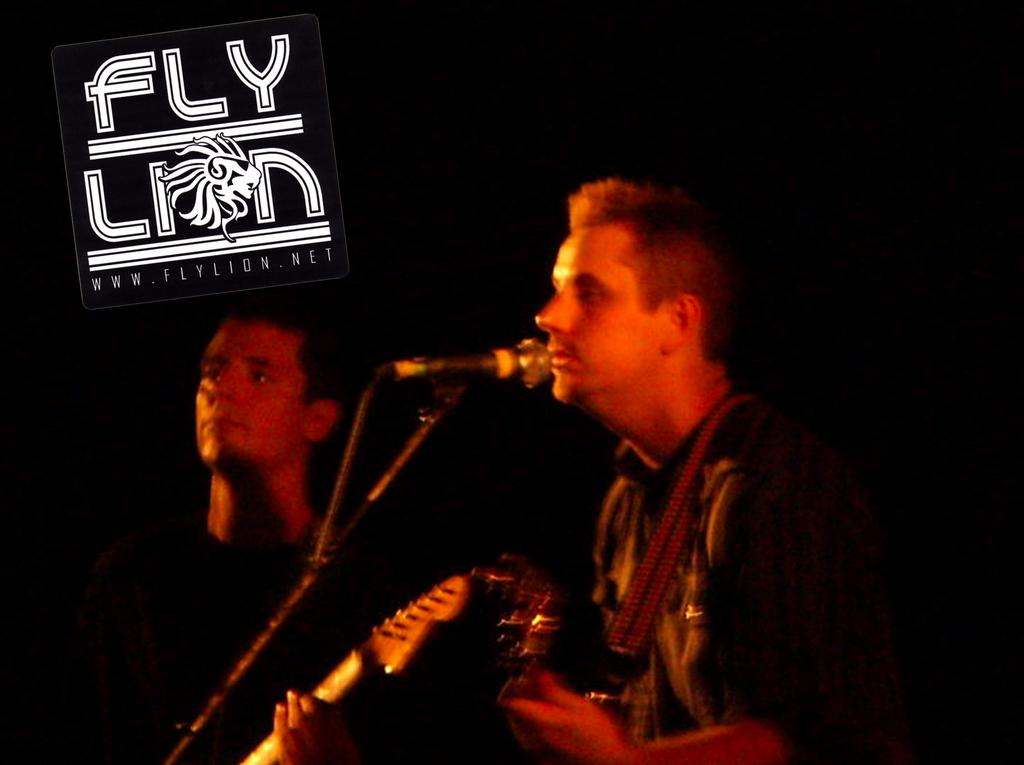How many people are in the image? There are two people in the image. What are the two people holding in the image? The two people are holding guitars. Can you describe any other objects in the image? Yes, there is a mic with a stand in the image. What type of orange can be seen in the image? There is no orange present in the image. Can you tell me how many hens are visible in the image? There are no hens present in the image. What type of creature is the jellyfish in the image? There is no jellyfish present in the image. 